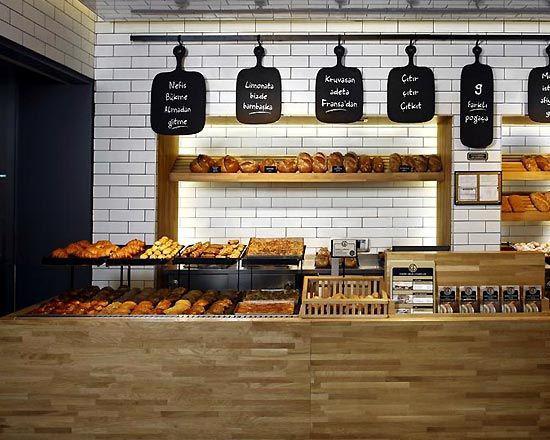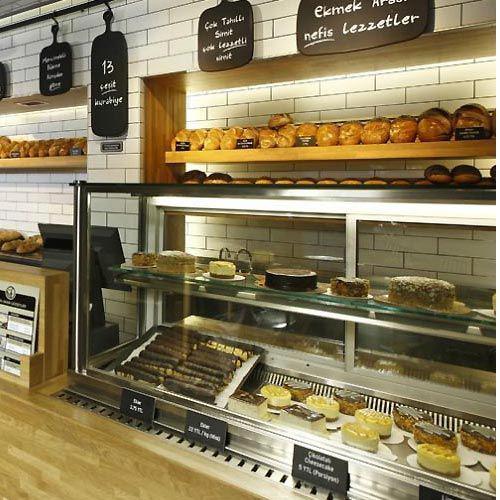The first image is the image on the left, the second image is the image on the right. For the images displayed, is the sentence "Right image includes a row of at least 3 pendant lights." factually correct? Answer yes or no. No. The first image is the image on the left, the second image is the image on the right. Given the left and right images, does the statement "There are exactly three white lights hanging over the counter in one of the images" hold true? Answer yes or no. No. 